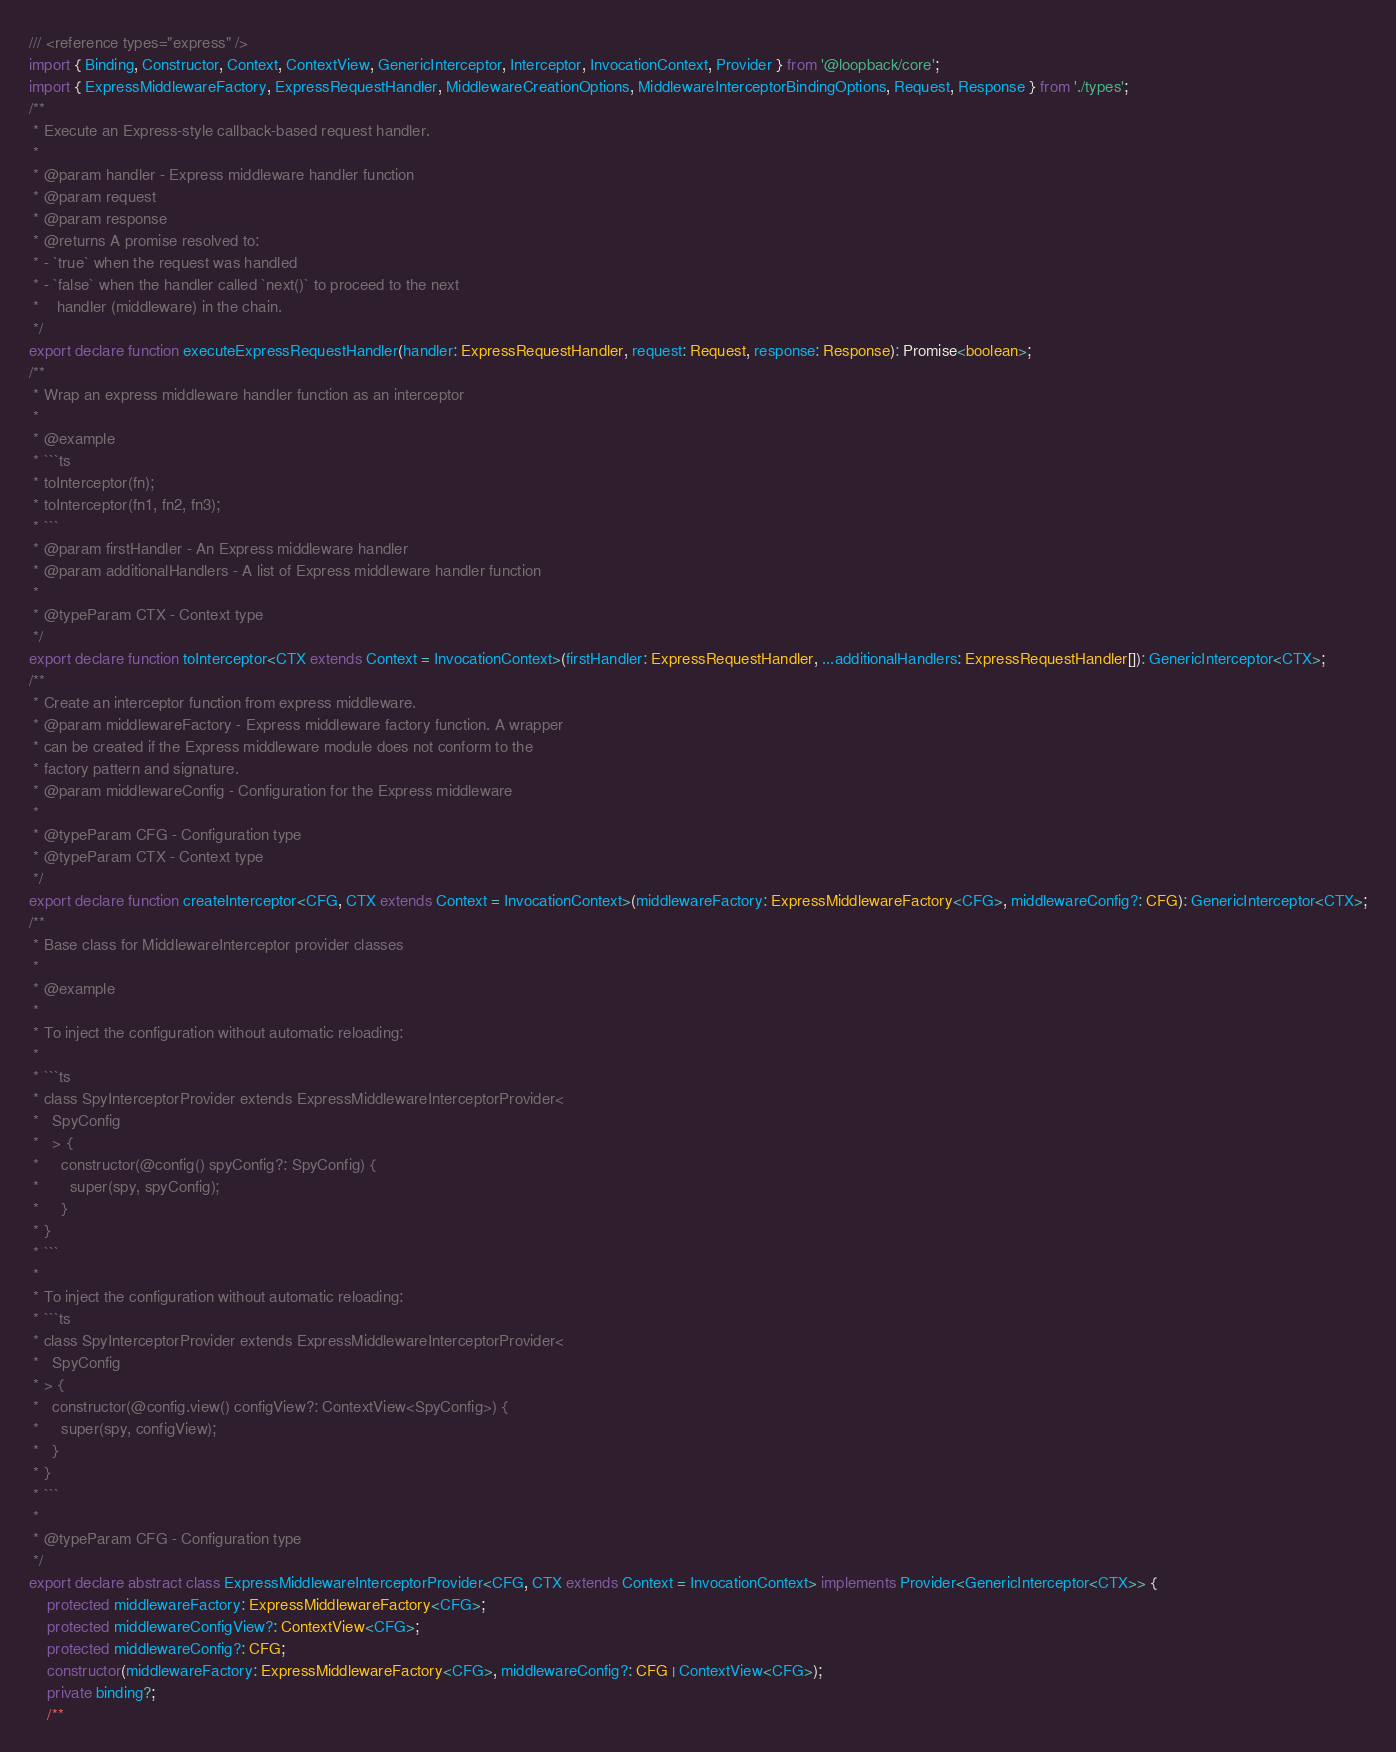Convert code to text. <code><loc_0><loc_0><loc_500><loc_500><_TypeScript_>/// <reference types="express" />
import { Binding, Constructor, Context, ContextView, GenericInterceptor, Interceptor, InvocationContext, Provider } from '@loopback/core';
import { ExpressMiddlewareFactory, ExpressRequestHandler, MiddlewareCreationOptions, MiddlewareInterceptorBindingOptions, Request, Response } from './types';
/**
 * Execute an Express-style callback-based request handler.
 *
 * @param handler - Express middleware handler function
 * @param request
 * @param response
 * @returns A promise resolved to:
 * - `true` when the request was handled
 * - `false` when the handler called `next()` to proceed to the next
 *    handler (middleware) in the chain.
 */
export declare function executeExpressRequestHandler(handler: ExpressRequestHandler, request: Request, response: Response): Promise<boolean>;
/**
 * Wrap an express middleware handler function as an interceptor
 *
 * @example
 * ```ts
 * toInterceptor(fn);
 * toInterceptor(fn1, fn2, fn3);
 * ```
 * @param firstHandler - An Express middleware handler
 * @param additionalHandlers - A list of Express middleware handler function
 *
 * @typeParam CTX - Context type
 */
export declare function toInterceptor<CTX extends Context = InvocationContext>(firstHandler: ExpressRequestHandler, ...additionalHandlers: ExpressRequestHandler[]): GenericInterceptor<CTX>;
/**
 * Create an interceptor function from express middleware.
 * @param middlewareFactory - Express middleware factory function. A wrapper
 * can be created if the Express middleware module does not conform to the
 * factory pattern and signature.
 * @param middlewareConfig - Configuration for the Express middleware
 *
 * @typeParam CFG - Configuration type
 * @typeParam CTX - Context type
 */
export declare function createInterceptor<CFG, CTX extends Context = InvocationContext>(middlewareFactory: ExpressMiddlewareFactory<CFG>, middlewareConfig?: CFG): GenericInterceptor<CTX>;
/**
 * Base class for MiddlewareInterceptor provider classes
 *
 * @example
 *
 * To inject the configuration without automatic reloading:
 *
 * ```ts
 * class SpyInterceptorProvider extends ExpressMiddlewareInterceptorProvider<
 *   SpyConfig
 *   > {
 *     constructor(@config() spyConfig?: SpyConfig) {
 *       super(spy, spyConfig);
 *     }
 * }
 * ```
 *
 * To inject the configuration without automatic reloading:
 * ```ts
 * class SpyInterceptorProvider extends ExpressMiddlewareInterceptorProvider<
 *   SpyConfig
 * > {
 *   constructor(@config.view() configView?: ContextView<SpyConfig>) {
 *     super(spy, configView);
 *   }
 * }
 * ```
 *
 * @typeParam CFG - Configuration type
 */
export declare abstract class ExpressMiddlewareInterceptorProvider<CFG, CTX extends Context = InvocationContext> implements Provider<GenericInterceptor<CTX>> {
    protected middlewareFactory: ExpressMiddlewareFactory<CFG>;
    protected middlewareConfigView?: ContextView<CFG>;
    protected middlewareConfig?: CFG;
    constructor(middlewareFactory: ExpressMiddlewareFactory<CFG>, middlewareConfig?: CFG | ContextView<CFG>);
    private binding?;
    /**</code> 